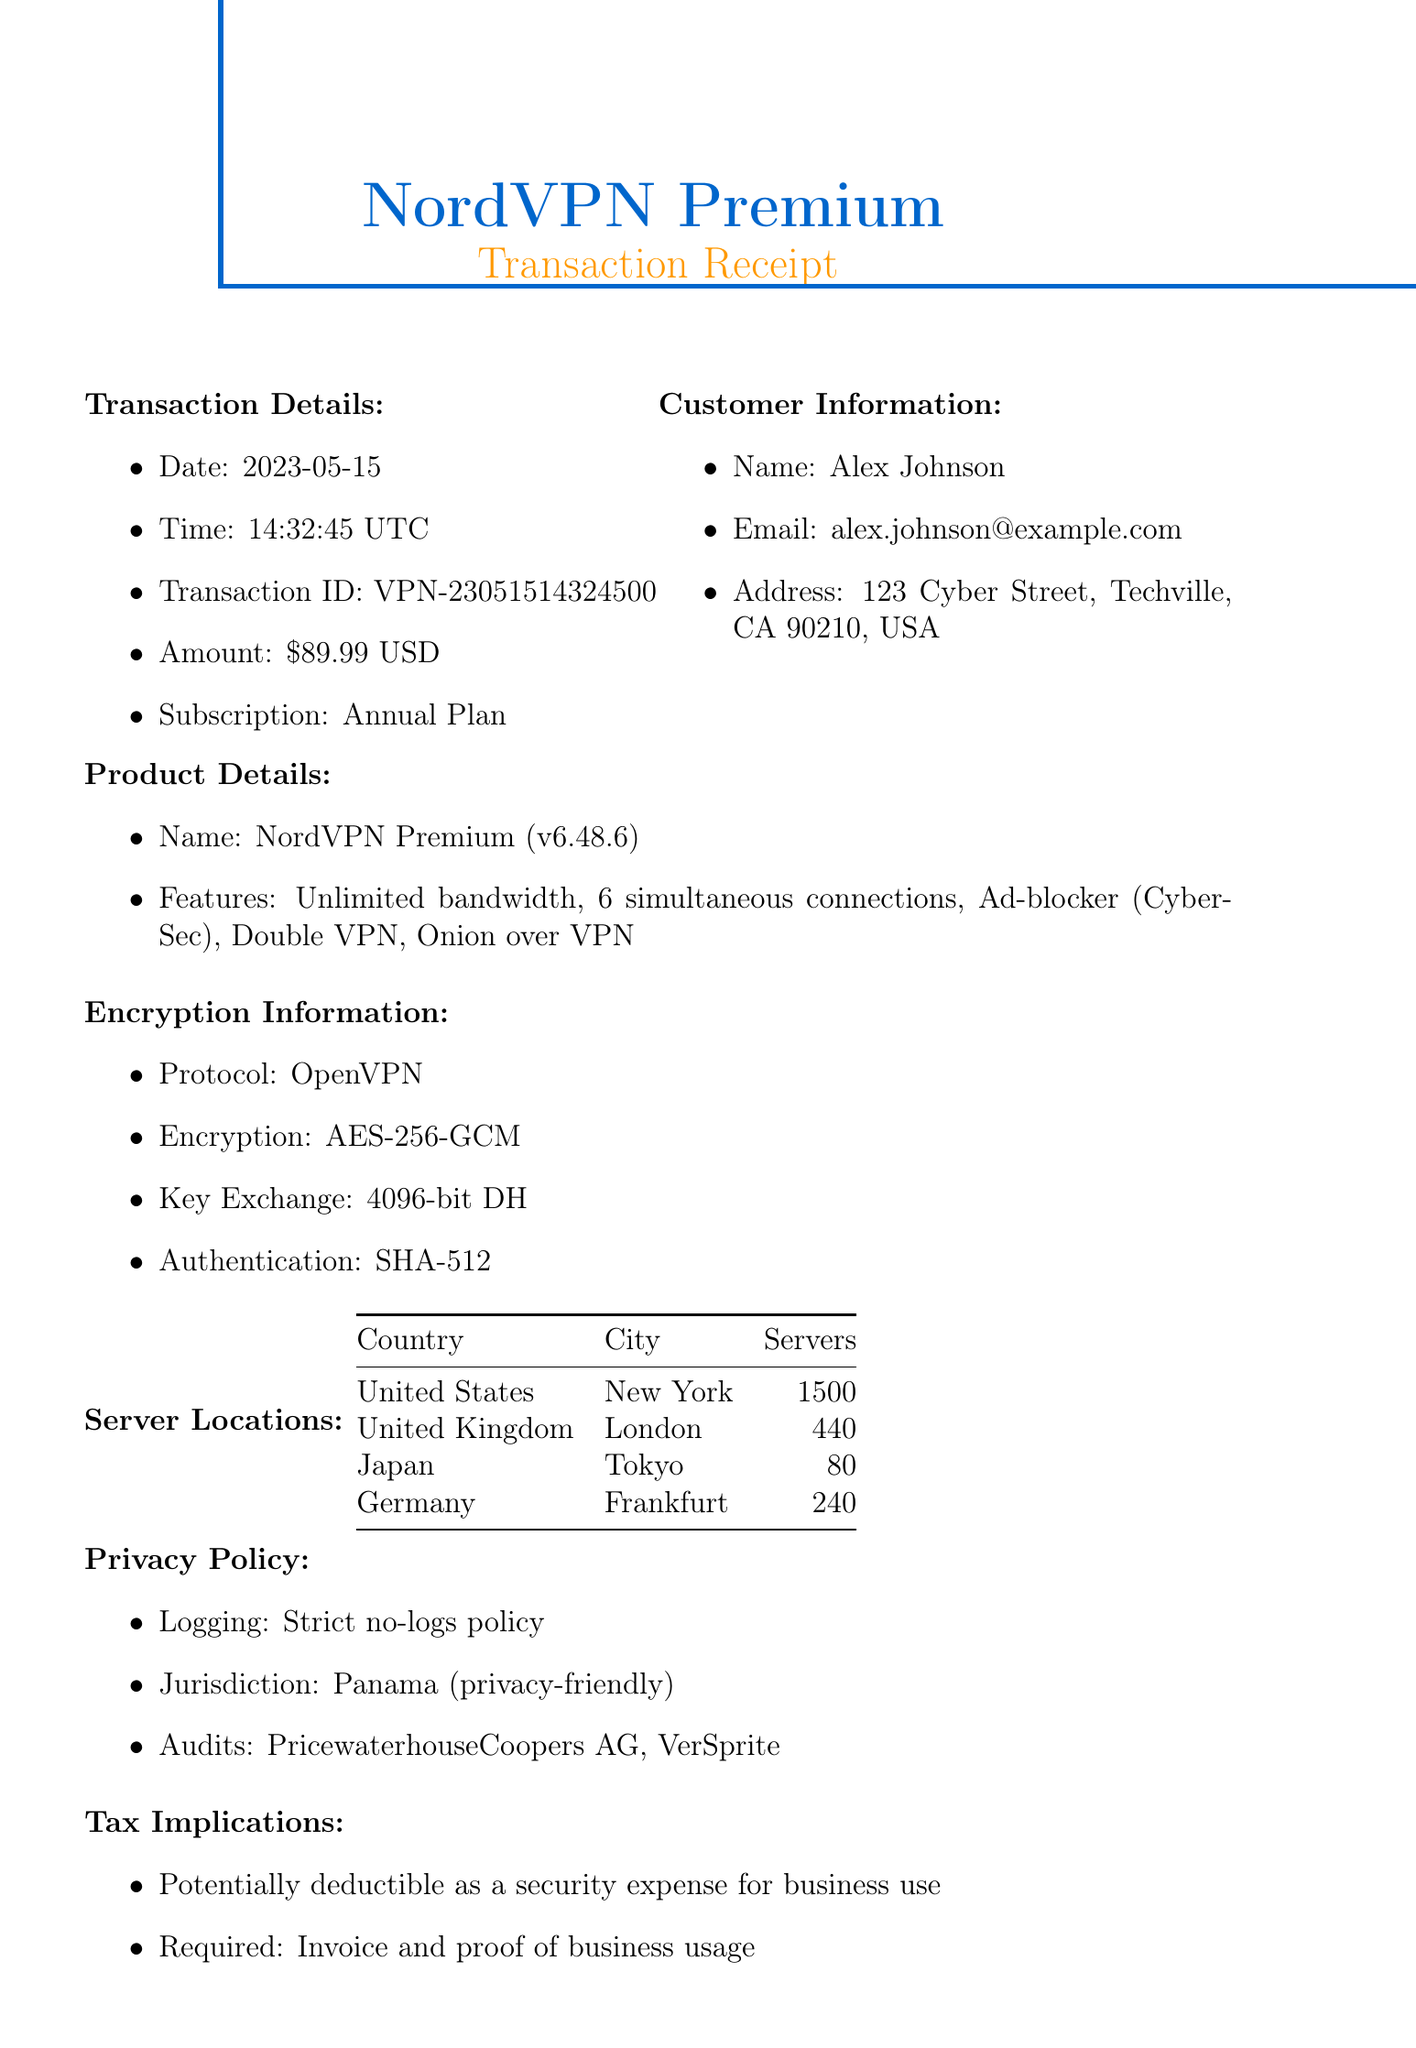What is the transaction date? The transaction date is given in the document as the specific day when the purchase occurred.
Answer: 2023-05-15 What is the payment method used? The payment method is specified in the document, indicating how the payment was made.
Answer: Credit Card (Visa ending in 4321) How much did the VPN service cost? The document states the amount charged for the VPN service, which is the total price.
Answer: $89.99 What encryption algorithm is used? The encryption algorithm is mentioned in the encryption information section of the document, detailing the security measure applied.
Answer: AES-256-GCM How many servers are located in New York? The document lists the number of servers available in each location, specifying the count for New York.
Answer: 1500 What is the jurisdiction of the privacy policy? The privacy policy details the legal jurisdiction under which the service operates, as mentioned in the document.
Answer: Panama (privacy-friendly) What features does the VPN provide? The document outlines key features of the VPN service, summarizing the functionalities that come with it.
Answer: Unlimited bandwidth, 6 simultaneous connections, Ad-blocker (CyberSec), Double VPN, Onion over VPN What is the average response time for customer support? The document provides information on the expected response time for customer support inquiries.
Answer: Under 1 hour Is the service potentially deductible? The tax implications section indicates whether the service may be deducted for tax purposes based on its usage.
Answer: Potentially deductible as a security expense for business use 